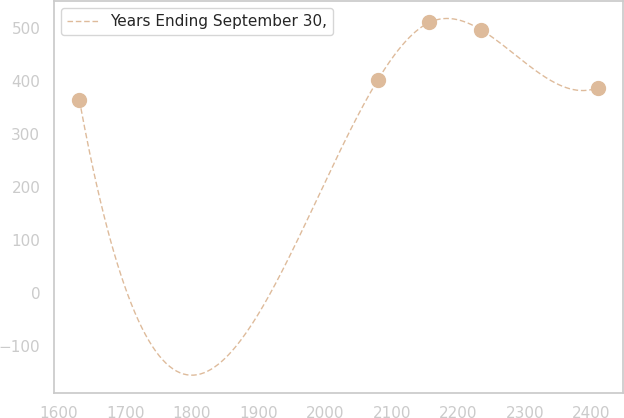<chart> <loc_0><loc_0><loc_500><loc_500><line_chart><ecel><fcel>Years Ending September 30,<nl><fcel>1631.02<fcel>364.47<nl><fcel>2078.82<fcel>402.1<nl><fcel>2156.62<fcel>511.4<nl><fcel>2234.42<fcel>497.19<nl><fcel>2409.05<fcel>387.89<nl></chart> 